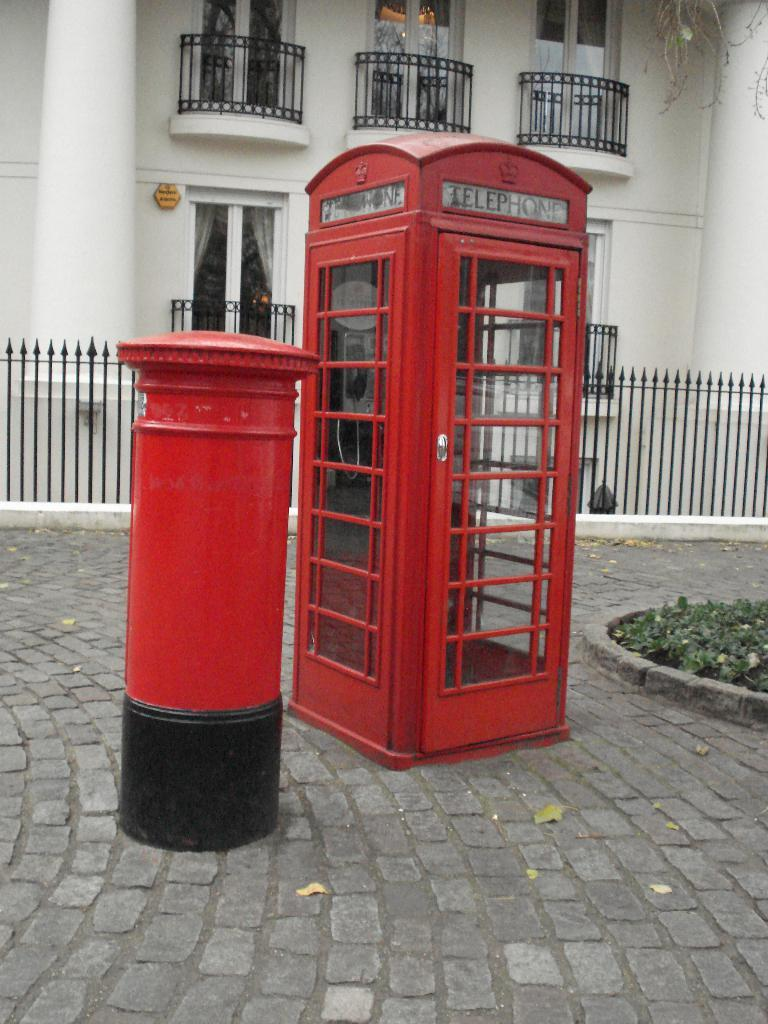<image>
Describe the image concisely. A red phone booth has a sign that says telephone on it. 